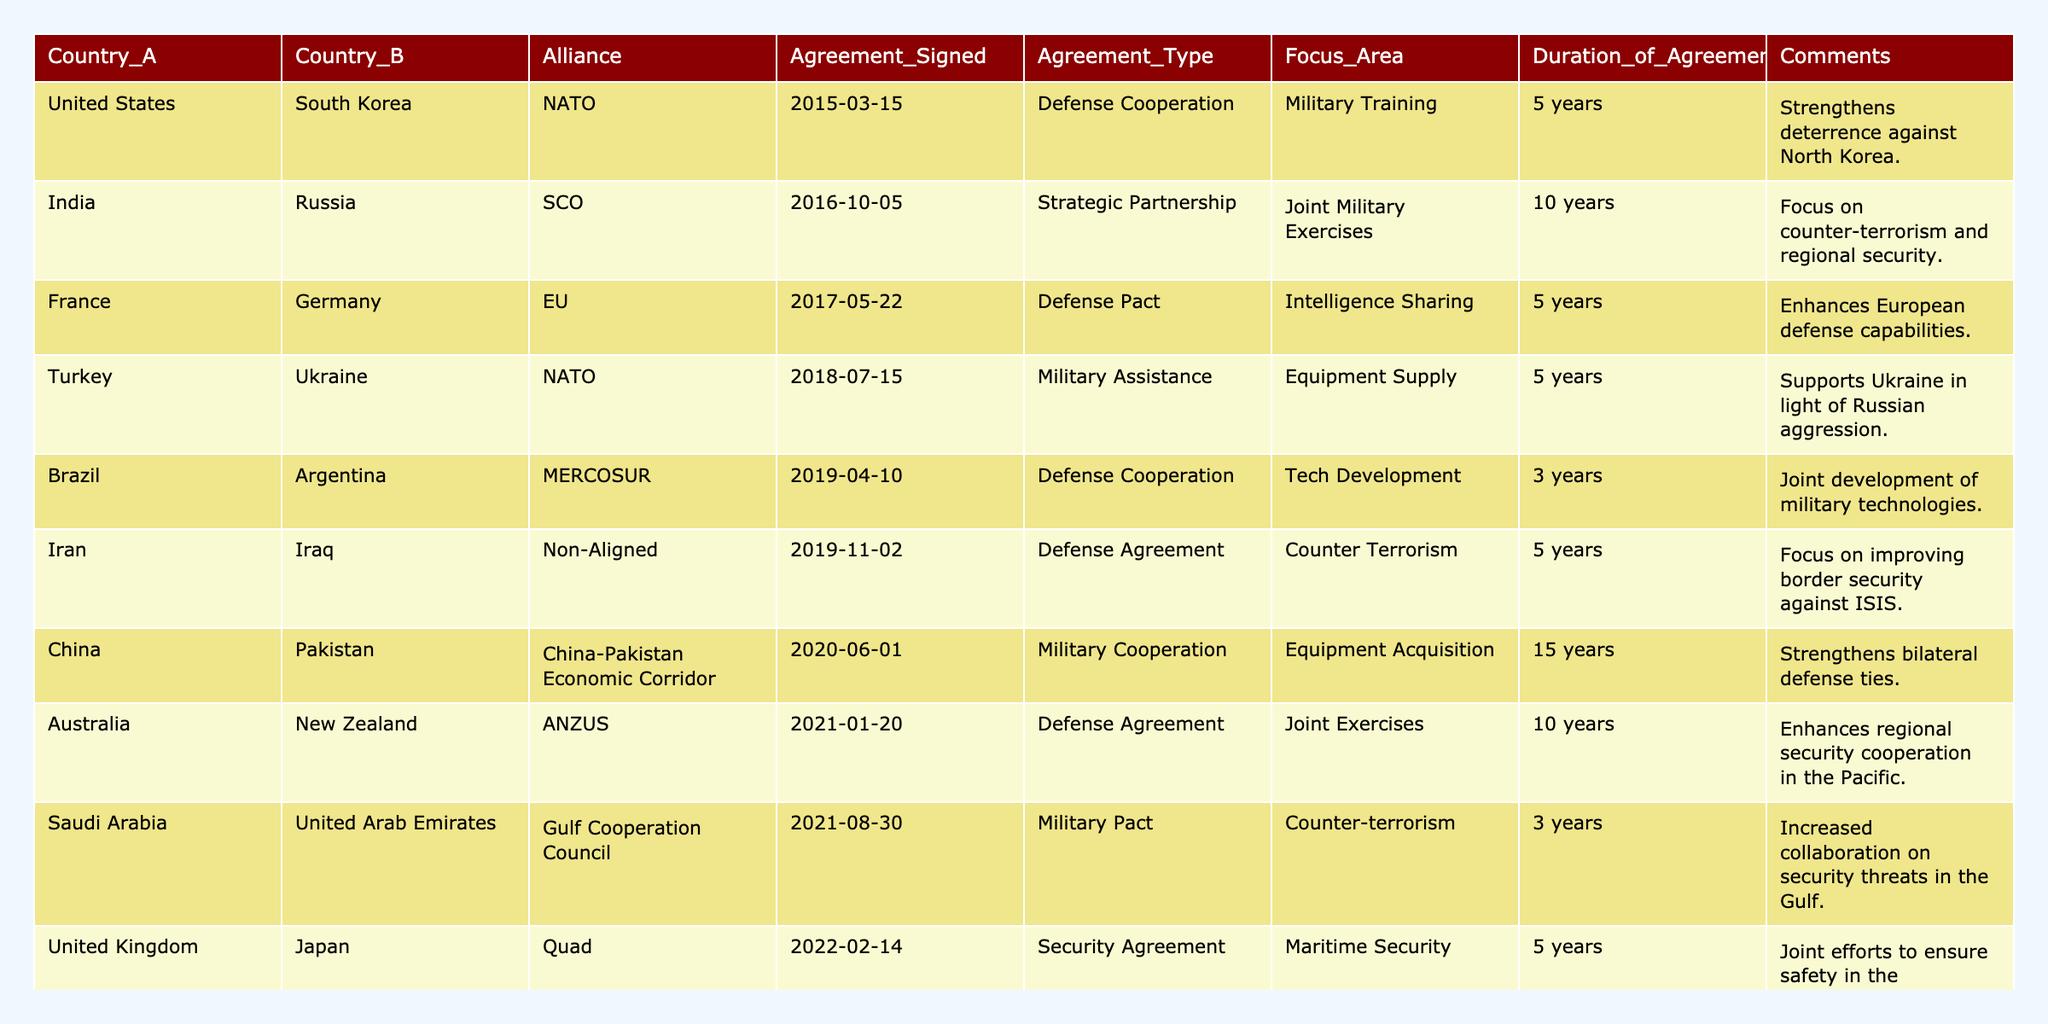What year was the military cooperation agreement between the United States and South Korea signed? The agreement between the United States and South Korea was signed in 2015, as shown in the table under the "Agreement Signed" column.
Answer: 2015 Which countries have agreements focused on counter-terrorism? The countries involved in agreements focused on counter-terrorism are Iran and Iraq, along with Saudi Arabia and the United Arab Emirates, as indicated in the "Focus Area" column.
Answer: Iran, Iraq, Saudi Arabia, United Arab Emirates What is the duration of the military cooperation agreement between China and Pakistan? The agreement duration between China and Pakistan is 15 years, as specified in the "Duration of Agreement" column.
Answer: 15 years How many agreements were signed in 2021? There are two agreements signed in 2021, which can be counted directly from the "Agreement Signed" column in that year.
Answer: 2 Is there a military agreement between any countries within MERCOSUR? Yes, Brazil and Argentina have a defense cooperation agreement as part of MERCOSUR, as identified in the "Alliance" column.
Answer: Yes What type of agreement is signed between India and Russia? The type of agreement between India and Russia is a Strategic Partnership focused on Joint Military Exercises, as indicated in the "Agreement Type" column.
Answer: Strategic Partnership Which alliance has the highest number of military cooperation agreements based on the table? The NATO alliance has the highest number of agreements with 3 entries (the United States with South Korea, Turkey with Ukraine, and the United Kingdom with Japan), compared to other alliances.
Answer: NATO What are the focus areas for the agreements signed in 2018? The focus area for the agreements signed in 2018 is Military Assistance for Turkey and Ukraine, and Counter-terrorism for nations like Iran and Iraq, indicating varying focus areas.
Answer: Military Assistance, Counter-terrorism List all countries that have signed agreements related to military training. The countries that have signed agreements related to military training are the United States (with South Korea) and Australia (with New Zealand) based on the "Focus Area" column.
Answer: United States, Australia Calculate the average duration of agreements signed in the last decade. The sum of durations is 5 + 10 + 5 + 5 + 3 + 5 + 15 + 10 + 3 + 5 = 66 years, and since there are 10 agreements, the average duration is 66/10 = 6.6 years.
Answer: 6.6 years Which country has the longest military cooperation agreement duration? China and Pakistan have the longest military cooperation agreement with a duration of 15 years, as noted in the "Duration of Agreement" column.
Answer: China, Pakistan 